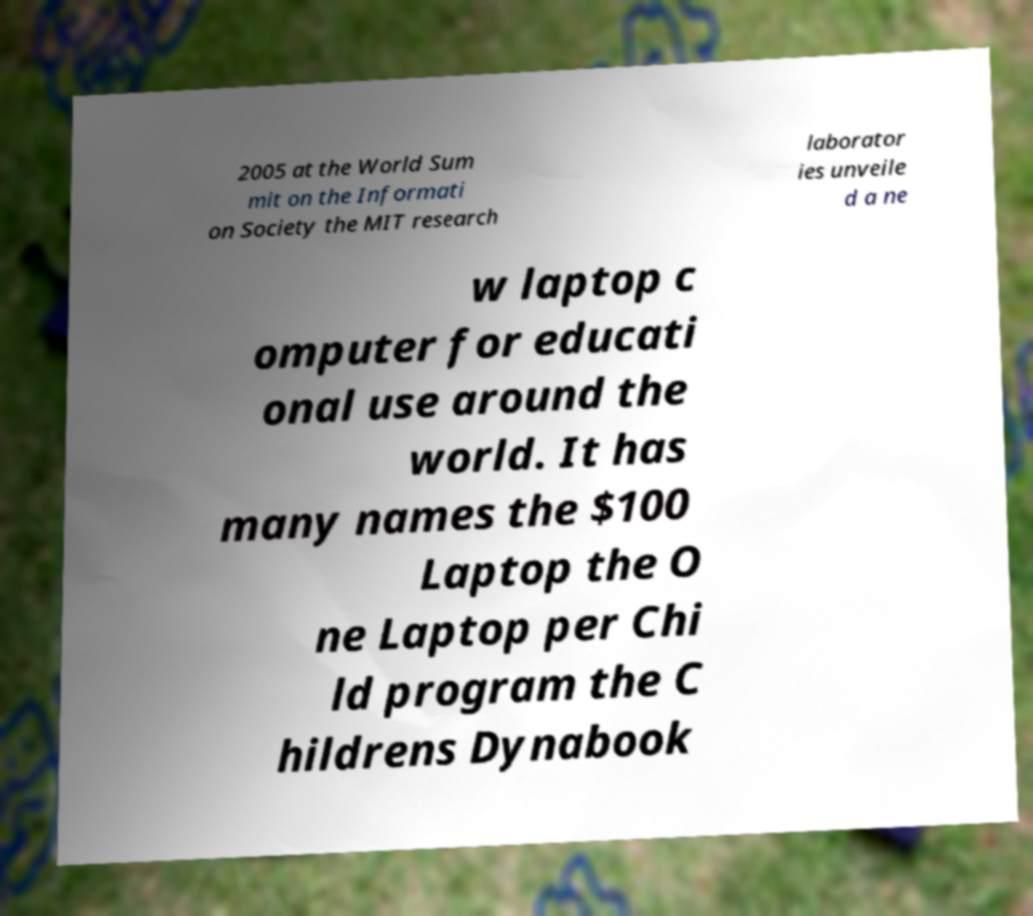What messages or text are displayed in this image? I need them in a readable, typed format. 2005 at the World Sum mit on the Informati on Society the MIT research laborator ies unveile d a ne w laptop c omputer for educati onal use around the world. It has many names the $100 Laptop the O ne Laptop per Chi ld program the C hildrens Dynabook 